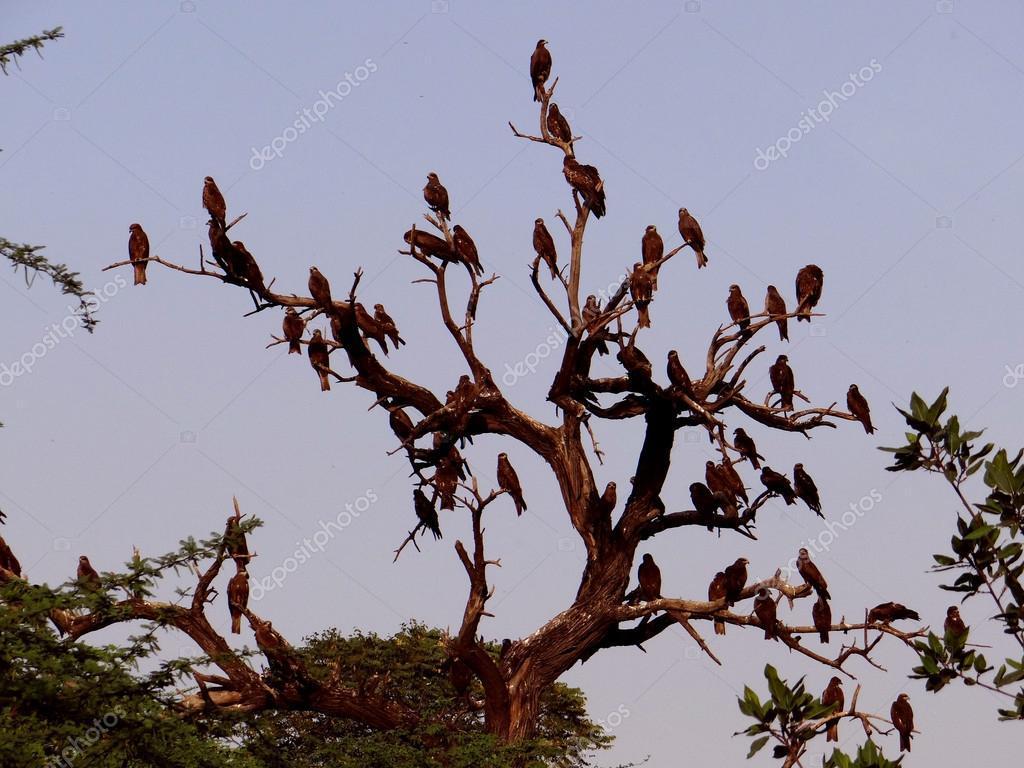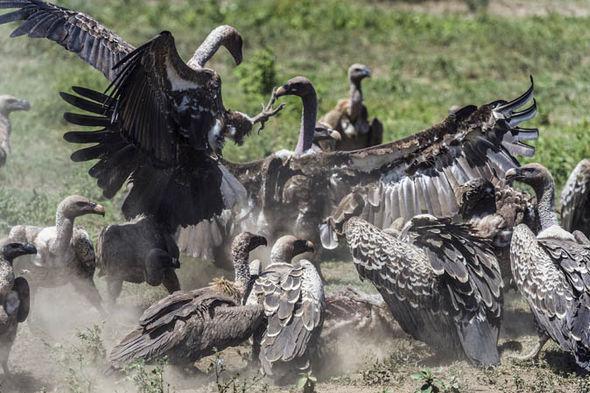The first image is the image on the left, the second image is the image on the right. Examine the images to the left and right. Is the description "At least one bird is flying in the air." accurate? Answer yes or no. No. 